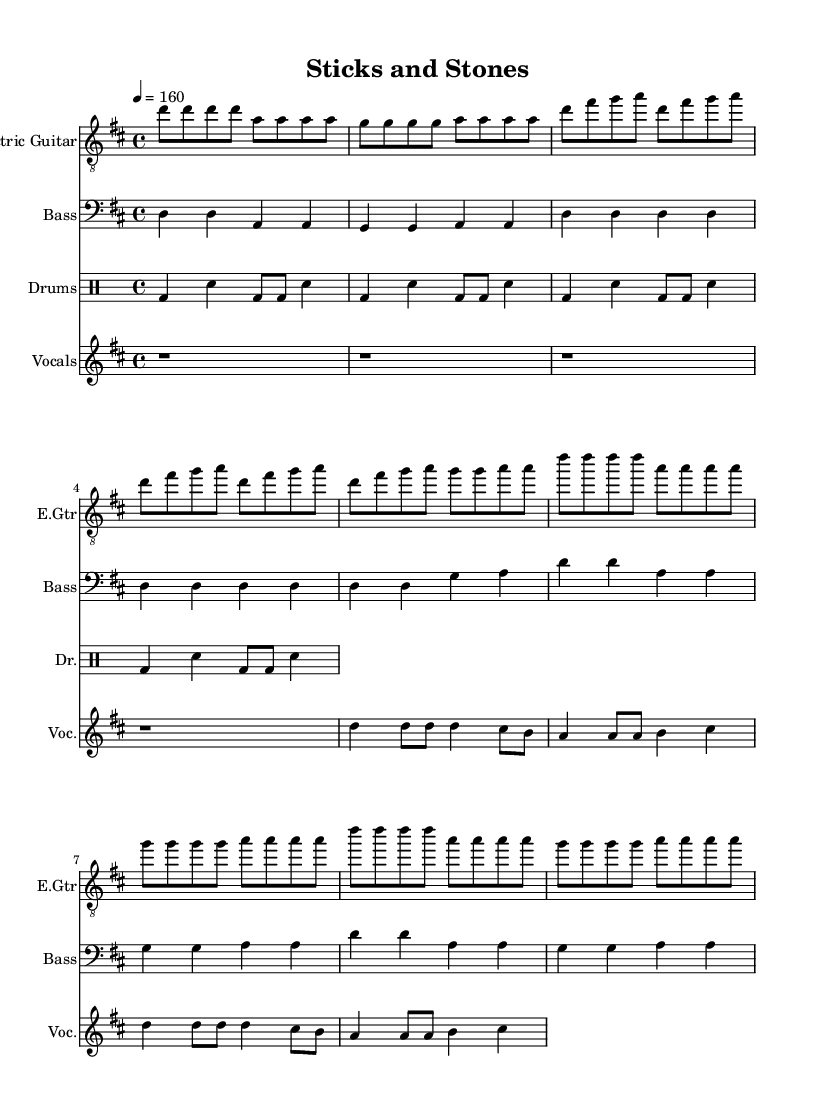What is the key signature of this music? The key signature is D major, which has two sharps (F# and C#). This is determined by looking at the symbol at the beginning of the staff that indicates the key.
Answer: D major What is the time signature of this music? The time signature is 4/4, which is indicated at the beginning of the score next to the key signature. This means there are four beats in each measure and a quarter note gets one beat.
Answer: 4/4 What is the tempo of the piece? The tempo marking at the beginning states "4 = 160," meaning there are 160 quarter note beats per minute. This is typically found under a tempo indication marking or at the beginning of the music.
Answer: 160 How many measures are in the verse section? The verse section consists of four measures, as indicated by counting the number of vertical lines separating the music notes in this respective section. Each measure is delineated by a bar line.
Answer: 4 What instruments are included in this score? The score contains four instruments: Electric Guitar, Bass, Drums, and Vocals. The names of the instruments are listed at the beginning of each staff.
Answer: Electric Guitar, Bass, Drums, Vocals What is the main lyrical theme of the chorus? The main lyrical theme of the chorus centers around resilience and empowerment, specifically stating "Sticks and stones won't break these bones I'm a champion, and it shows." This can be inferred from the lyrics written beneath the vocal part.
Answer: Resilience and empowerment Which section of the song is typically characterized by a loud and energetic performance? The chorus of the song is where the performance style is notably loud and energetic, as it usually heightens intensity in punk music, distinguishing it from the verse. This is often felt in the heightened dynamics and repetitive melodic phrases in the score.
Answer: Chorus 